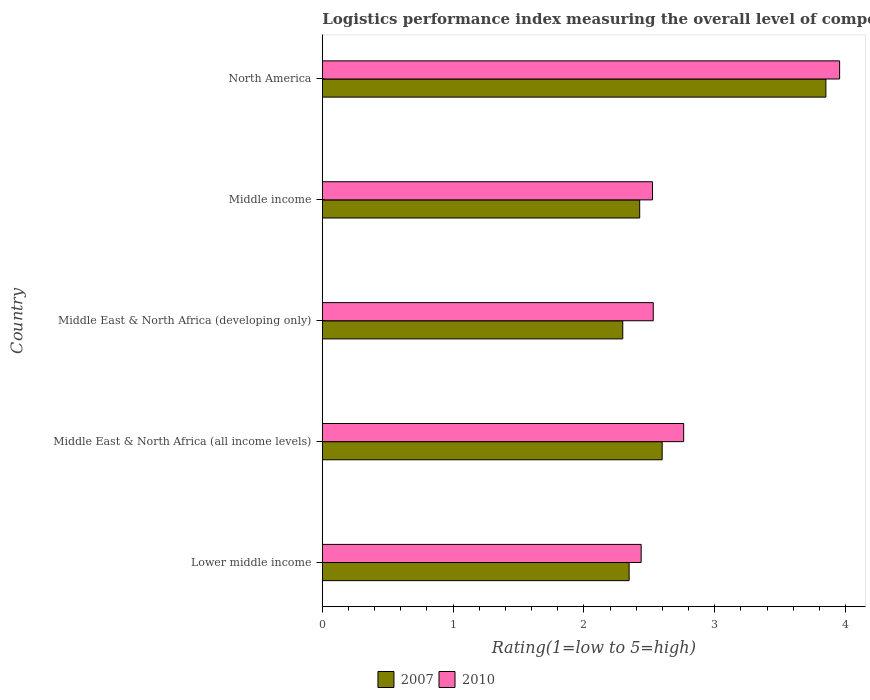Are the number of bars per tick equal to the number of legend labels?
Your answer should be very brief. Yes. Are the number of bars on each tick of the Y-axis equal?
Make the answer very short. Yes. What is the Logistic performance index in 2007 in North America?
Provide a short and direct response. 3.85. Across all countries, what is the maximum Logistic performance index in 2010?
Offer a very short reply. 3.96. Across all countries, what is the minimum Logistic performance index in 2010?
Give a very brief answer. 2.44. In which country was the Logistic performance index in 2007 minimum?
Your response must be concise. Middle East & North Africa (developing only). What is the total Logistic performance index in 2010 in the graph?
Ensure brevity in your answer.  14.21. What is the difference between the Logistic performance index in 2010 in Lower middle income and that in Middle East & North Africa (all income levels)?
Make the answer very short. -0.32. What is the difference between the Logistic performance index in 2007 in Middle East & North Africa (all income levels) and the Logistic performance index in 2010 in Middle East & North Africa (developing only)?
Your response must be concise. 0.07. What is the average Logistic performance index in 2010 per country?
Your answer should be very brief. 2.84. What is the difference between the Logistic performance index in 2007 and Logistic performance index in 2010 in Lower middle income?
Offer a terse response. -0.09. What is the ratio of the Logistic performance index in 2007 in Middle East & North Africa (all income levels) to that in Middle income?
Keep it short and to the point. 1.07. What is the difference between the highest and the second highest Logistic performance index in 2007?
Offer a terse response. 1.25. What is the difference between the highest and the lowest Logistic performance index in 2010?
Provide a succinct answer. 1.52. In how many countries, is the Logistic performance index in 2007 greater than the average Logistic performance index in 2007 taken over all countries?
Offer a terse response. 1. What does the 1st bar from the top in Lower middle income represents?
Keep it short and to the point. 2010. What does the 2nd bar from the bottom in Middle East & North Africa (all income levels) represents?
Keep it short and to the point. 2010. Are all the bars in the graph horizontal?
Your response must be concise. Yes. Does the graph contain any zero values?
Keep it short and to the point. No. How are the legend labels stacked?
Provide a succinct answer. Horizontal. What is the title of the graph?
Offer a very short reply. Logistics performance index measuring the overall level of competence and quality of logistics services. What is the label or title of the X-axis?
Give a very brief answer. Rating(1=low to 5=high). What is the label or title of the Y-axis?
Keep it short and to the point. Country. What is the Rating(1=low to 5=high) in 2007 in Lower middle income?
Your response must be concise. 2.35. What is the Rating(1=low to 5=high) in 2010 in Lower middle income?
Give a very brief answer. 2.44. What is the Rating(1=low to 5=high) of 2007 in Middle East & North Africa (all income levels)?
Give a very brief answer. 2.6. What is the Rating(1=low to 5=high) of 2010 in Middle East & North Africa (all income levels)?
Keep it short and to the point. 2.76. What is the Rating(1=low to 5=high) in 2007 in Middle East & North Africa (developing only)?
Make the answer very short. 2.3. What is the Rating(1=low to 5=high) of 2010 in Middle East & North Africa (developing only)?
Ensure brevity in your answer.  2.53. What is the Rating(1=low to 5=high) in 2007 in Middle income?
Provide a succinct answer. 2.43. What is the Rating(1=low to 5=high) of 2010 in Middle income?
Your response must be concise. 2.52. What is the Rating(1=low to 5=high) of 2007 in North America?
Provide a short and direct response. 3.85. What is the Rating(1=low to 5=high) of 2010 in North America?
Your response must be concise. 3.96. Across all countries, what is the maximum Rating(1=low to 5=high) of 2007?
Make the answer very short. 3.85. Across all countries, what is the maximum Rating(1=low to 5=high) in 2010?
Your answer should be compact. 3.96. Across all countries, what is the minimum Rating(1=low to 5=high) of 2007?
Your answer should be compact. 2.3. Across all countries, what is the minimum Rating(1=low to 5=high) in 2010?
Provide a succinct answer. 2.44. What is the total Rating(1=low to 5=high) in 2007 in the graph?
Your answer should be very brief. 13.52. What is the total Rating(1=low to 5=high) of 2010 in the graph?
Make the answer very short. 14.21. What is the difference between the Rating(1=low to 5=high) in 2007 in Lower middle income and that in Middle East & North Africa (all income levels)?
Your response must be concise. -0.25. What is the difference between the Rating(1=low to 5=high) of 2010 in Lower middle income and that in Middle East & North Africa (all income levels)?
Your response must be concise. -0.33. What is the difference between the Rating(1=low to 5=high) of 2007 in Lower middle income and that in Middle East & North Africa (developing only)?
Provide a short and direct response. 0.05. What is the difference between the Rating(1=low to 5=high) in 2010 in Lower middle income and that in Middle East & North Africa (developing only)?
Provide a short and direct response. -0.09. What is the difference between the Rating(1=low to 5=high) of 2007 in Lower middle income and that in Middle income?
Ensure brevity in your answer.  -0.08. What is the difference between the Rating(1=low to 5=high) of 2010 in Lower middle income and that in Middle income?
Provide a succinct answer. -0.09. What is the difference between the Rating(1=low to 5=high) in 2007 in Lower middle income and that in North America?
Offer a terse response. -1.5. What is the difference between the Rating(1=low to 5=high) in 2010 in Lower middle income and that in North America?
Offer a terse response. -1.52. What is the difference between the Rating(1=low to 5=high) of 2007 in Middle East & North Africa (all income levels) and that in Middle East & North Africa (developing only)?
Provide a succinct answer. 0.3. What is the difference between the Rating(1=low to 5=high) in 2010 in Middle East & North Africa (all income levels) and that in Middle East & North Africa (developing only)?
Your answer should be compact. 0.23. What is the difference between the Rating(1=low to 5=high) in 2007 in Middle East & North Africa (all income levels) and that in Middle income?
Provide a succinct answer. 0.17. What is the difference between the Rating(1=low to 5=high) of 2010 in Middle East & North Africa (all income levels) and that in Middle income?
Give a very brief answer. 0.24. What is the difference between the Rating(1=low to 5=high) of 2007 in Middle East & North Africa (all income levels) and that in North America?
Offer a very short reply. -1.25. What is the difference between the Rating(1=low to 5=high) of 2010 in Middle East & North Africa (all income levels) and that in North America?
Keep it short and to the point. -1.19. What is the difference between the Rating(1=low to 5=high) of 2007 in Middle East & North Africa (developing only) and that in Middle income?
Make the answer very short. -0.13. What is the difference between the Rating(1=low to 5=high) of 2010 in Middle East & North Africa (developing only) and that in Middle income?
Keep it short and to the point. 0.01. What is the difference between the Rating(1=low to 5=high) in 2007 in Middle East & North Africa (developing only) and that in North America?
Ensure brevity in your answer.  -1.55. What is the difference between the Rating(1=low to 5=high) of 2010 in Middle East & North Africa (developing only) and that in North America?
Keep it short and to the point. -1.43. What is the difference between the Rating(1=low to 5=high) in 2007 in Middle income and that in North America?
Provide a short and direct response. -1.42. What is the difference between the Rating(1=low to 5=high) in 2010 in Middle income and that in North America?
Provide a short and direct response. -1.43. What is the difference between the Rating(1=low to 5=high) in 2007 in Lower middle income and the Rating(1=low to 5=high) in 2010 in Middle East & North Africa (all income levels)?
Your answer should be compact. -0.42. What is the difference between the Rating(1=low to 5=high) in 2007 in Lower middle income and the Rating(1=low to 5=high) in 2010 in Middle East & North Africa (developing only)?
Your answer should be very brief. -0.18. What is the difference between the Rating(1=low to 5=high) of 2007 in Lower middle income and the Rating(1=low to 5=high) of 2010 in Middle income?
Keep it short and to the point. -0.18. What is the difference between the Rating(1=low to 5=high) of 2007 in Lower middle income and the Rating(1=low to 5=high) of 2010 in North America?
Your answer should be compact. -1.61. What is the difference between the Rating(1=low to 5=high) of 2007 in Middle East & North Africa (all income levels) and the Rating(1=low to 5=high) of 2010 in Middle East & North Africa (developing only)?
Provide a succinct answer. 0.07. What is the difference between the Rating(1=low to 5=high) of 2007 in Middle East & North Africa (all income levels) and the Rating(1=low to 5=high) of 2010 in Middle income?
Give a very brief answer. 0.07. What is the difference between the Rating(1=low to 5=high) of 2007 in Middle East & North Africa (all income levels) and the Rating(1=low to 5=high) of 2010 in North America?
Keep it short and to the point. -1.36. What is the difference between the Rating(1=low to 5=high) of 2007 in Middle East & North Africa (developing only) and the Rating(1=low to 5=high) of 2010 in Middle income?
Your answer should be compact. -0.23. What is the difference between the Rating(1=low to 5=high) in 2007 in Middle East & North Africa (developing only) and the Rating(1=low to 5=high) in 2010 in North America?
Ensure brevity in your answer.  -1.66. What is the difference between the Rating(1=low to 5=high) of 2007 in Middle income and the Rating(1=low to 5=high) of 2010 in North America?
Keep it short and to the point. -1.53. What is the average Rating(1=low to 5=high) in 2007 per country?
Provide a succinct answer. 2.7. What is the average Rating(1=low to 5=high) in 2010 per country?
Provide a short and direct response. 2.84. What is the difference between the Rating(1=low to 5=high) of 2007 and Rating(1=low to 5=high) of 2010 in Lower middle income?
Offer a terse response. -0.09. What is the difference between the Rating(1=low to 5=high) in 2007 and Rating(1=low to 5=high) in 2010 in Middle East & North Africa (all income levels)?
Your answer should be very brief. -0.16. What is the difference between the Rating(1=low to 5=high) of 2007 and Rating(1=low to 5=high) of 2010 in Middle East & North Africa (developing only)?
Keep it short and to the point. -0.23. What is the difference between the Rating(1=low to 5=high) of 2007 and Rating(1=low to 5=high) of 2010 in Middle income?
Provide a short and direct response. -0.1. What is the difference between the Rating(1=low to 5=high) of 2007 and Rating(1=low to 5=high) of 2010 in North America?
Keep it short and to the point. -0.1. What is the ratio of the Rating(1=low to 5=high) in 2007 in Lower middle income to that in Middle East & North Africa (all income levels)?
Offer a very short reply. 0.9. What is the ratio of the Rating(1=low to 5=high) of 2010 in Lower middle income to that in Middle East & North Africa (all income levels)?
Make the answer very short. 0.88. What is the ratio of the Rating(1=low to 5=high) of 2007 in Lower middle income to that in Middle East & North Africa (developing only)?
Offer a very short reply. 1.02. What is the ratio of the Rating(1=low to 5=high) in 2010 in Lower middle income to that in Middle East & North Africa (developing only)?
Give a very brief answer. 0.96. What is the ratio of the Rating(1=low to 5=high) in 2007 in Lower middle income to that in Middle income?
Offer a very short reply. 0.97. What is the ratio of the Rating(1=low to 5=high) in 2010 in Lower middle income to that in Middle income?
Ensure brevity in your answer.  0.97. What is the ratio of the Rating(1=low to 5=high) in 2007 in Lower middle income to that in North America?
Your answer should be compact. 0.61. What is the ratio of the Rating(1=low to 5=high) of 2010 in Lower middle income to that in North America?
Offer a terse response. 0.62. What is the ratio of the Rating(1=low to 5=high) of 2007 in Middle East & North Africa (all income levels) to that in Middle East & North Africa (developing only)?
Your answer should be very brief. 1.13. What is the ratio of the Rating(1=low to 5=high) of 2010 in Middle East & North Africa (all income levels) to that in Middle East & North Africa (developing only)?
Your answer should be very brief. 1.09. What is the ratio of the Rating(1=low to 5=high) of 2007 in Middle East & North Africa (all income levels) to that in Middle income?
Your response must be concise. 1.07. What is the ratio of the Rating(1=low to 5=high) of 2010 in Middle East & North Africa (all income levels) to that in Middle income?
Ensure brevity in your answer.  1.09. What is the ratio of the Rating(1=low to 5=high) of 2007 in Middle East & North Africa (all income levels) to that in North America?
Give a very brief answer. 0.67. What is the ratio of the Rating(1=low to 5=high) in 2010 in Middle East & North Africa (all income levels) to that in North America?
Keep it short and to the point. 0.7. What is the ratio of the Rating(1=low to 5=high) in 2007 in Middle East & North Africa (developing only) to that in Middle income?
Provide a short and direct response. 0.95. What is the ratio of the Rating(1=low to 5=high) in 2010 in Middle East & North Africa (developing only) to that in Middle income?
Provide a short and direct response. 1. What is the ratio of the Rating(1=low to 5=high) in 2007 in Middle East & North Africa (developing only) to that in North America?
Make the answer very short. 0.6. What is the ratio of the Rating(1=low to 5=high) in 2010 in Middle East & North Africa (developing only) to that in North America?
Your answer should be compact. 0.64. What is the ratio of the Rating(1=low to 5=high) in 2007 in Middle income to that in North America?
Give a very brief answer. 0.63. What is the ratio of the Rating(1=low to 5=high) of 2010 in Middle income to that in North America?
Make the answer very short. 0.64. What is the difference between the highest and the second highest Rating(1=low to 5=high) in 2007?
Your answer should be compact. 1.25. What is the difference between the highest and the second highest Rating(1=low to 5=high) in 2010?
Provide a short and direct response. 1.19. What is the difference between the highest and the lowest Rating(1=low to 5=high) of 2007?
Keep it short and to the point. 1.55. What is the difference between the highest and the lowest Rating(1=low to 5=high) of 2010?
Make the answer very short. 1.52. 